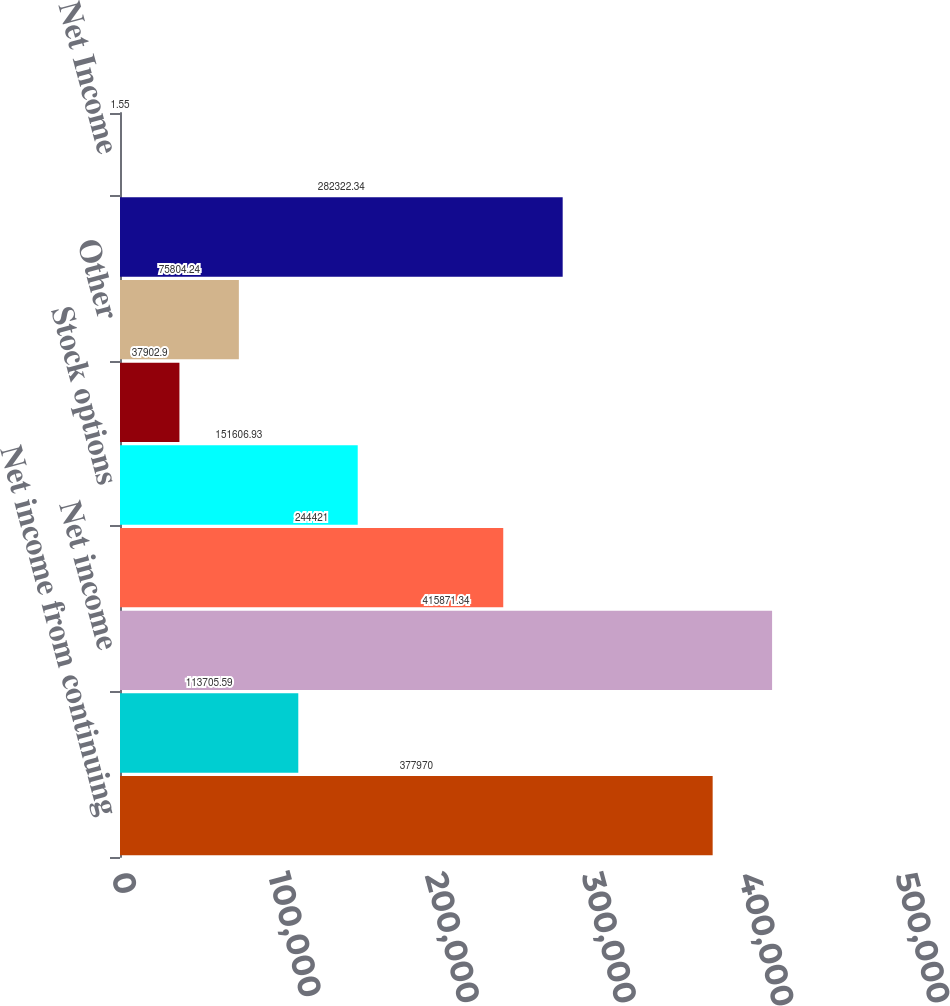Convert chart to OTSL. <chart><loc_0><loc_0><loc_500><loc_500><bar_chart><fcel>Net income from continuing<fcel>Net income from discontinued<fcel>Net income<fcel>Weighted-average common shares<fcel>Stock options<fcel>Unvested restricted stock and<fcel>Other<fcel>Shares used to compute diluted<fcel>Net Income<nl><fcel>377970<fcel>113706<fcel>415871<fcel>244421<fcel>151607<fcel>37902.9<fcel>75804.2<fcel>282322<fcel>1.55<nl></chart> 